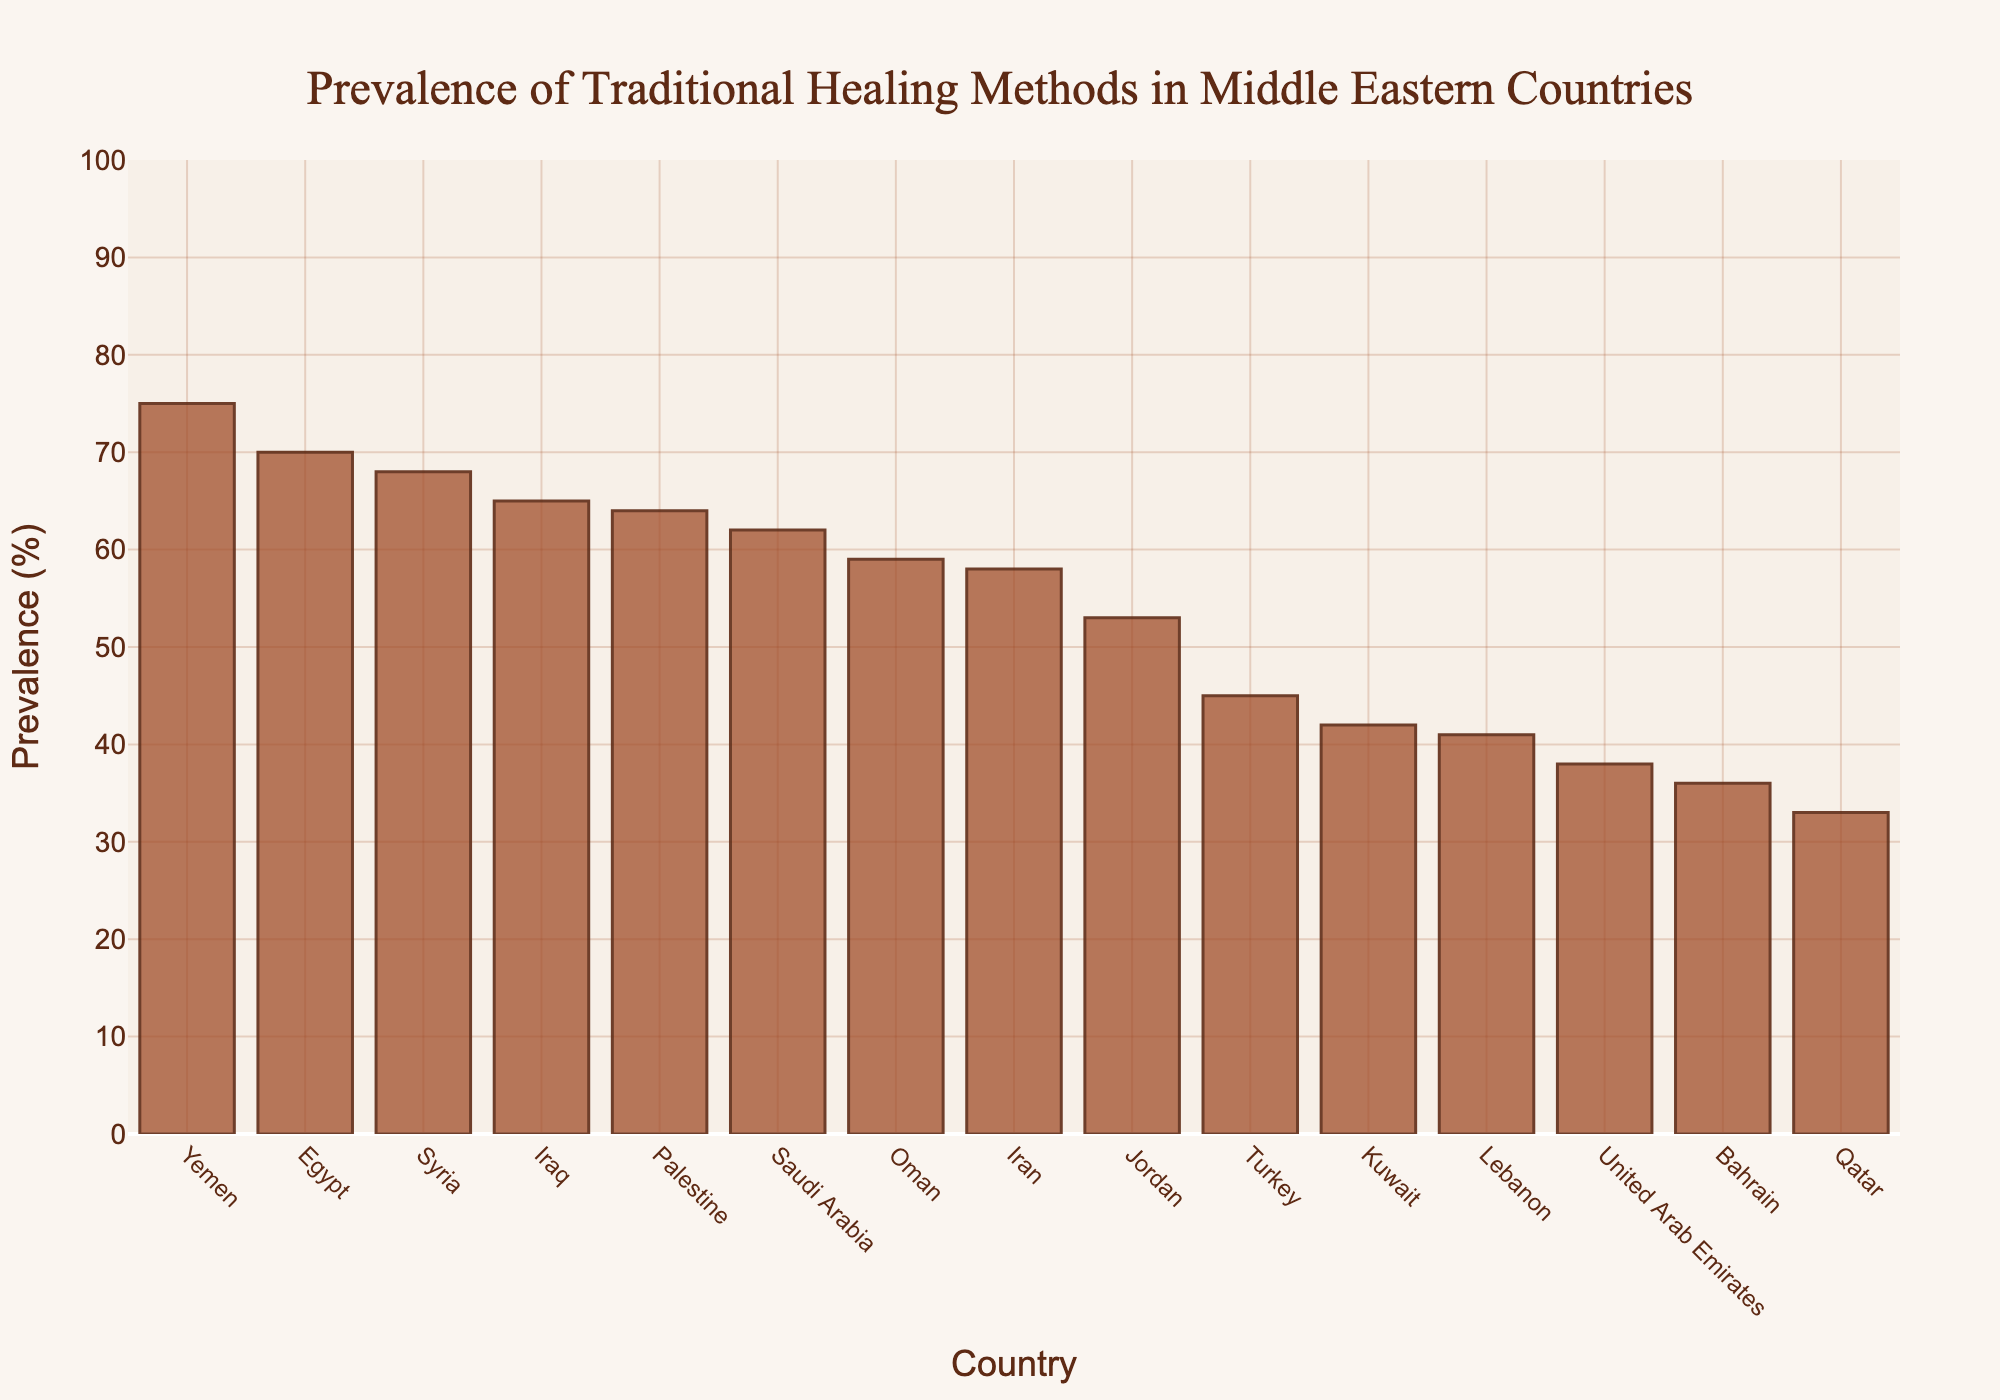Which country has the highest prevalence of traditional healing methods? Look for the tallest bar. It corresponds to Yemen with a prevalence of 75%.
Answer: Yemen How much higher is the prevalence of traditional healing methods in Egypt compared to Lebanon? The prevalence in Egypt is 70% and in Lebanon is 41%. The difference is 70 - 41 = 29%.
Answer: 29% Which countries have a prevalence of less than 40%? Identify the countries with bars below the 40% mark. These countries are Bahrain and Qatar.
Answer: Bahrain, Qatar What is the average prevalence of traditional healing methods in Iran, Oman, and Kuwait? Sum the prevalence in these countries: 58% (Iran) + 59% (Oman) + 42% (Kuwait) = 159%. Then, divide by the number of countries (3). Thus, 159 / 3 = 53%.
Answer: 53% Is the prevalence of traditional healing methods higher in Iraq or Jordan? Compare the heights of the bars for Iraq and Jordan. Iraq’s prevalence is 65%, while Jordan’s is 53%.
Answer: Iraq What is the total prevalence percentage for Saudi Arabia and Palestine combined? Add the prevalence percentages for the two countries: 62% (Saudi Arabia) + 64% (Palestine) = 126%.
Answer: 126% Identify the country with the lowest prevalence of traditional healing methods. Look for the shortest bar. It represents Qatar with a prevalence of 33%.
Answer: Qatar By how much does the prevalence of traditional healing methods in Syria exceed that of Turkey? Syria's prevalence is 68% and Turkey's is 45%. The difference is 68 - 45 = 23%.
Answer: 23% Rank the top three countries with the highest prevalence. Order the countries by the height of their bars, from highest to third highest: Yemen (75%), Egypt (70%), and Syria (68%).
Answer: Yemen, Egypt, Syria What’s the combined prevalence percentage for Bahrain, Qatar, and United Arab Emirates? Sum the prevalence percentages for Bahrain (36%), Qatar (33%), and United Arab Emirates (38%): 36 + 33 + 38 = 107%.
Answer: 107% 